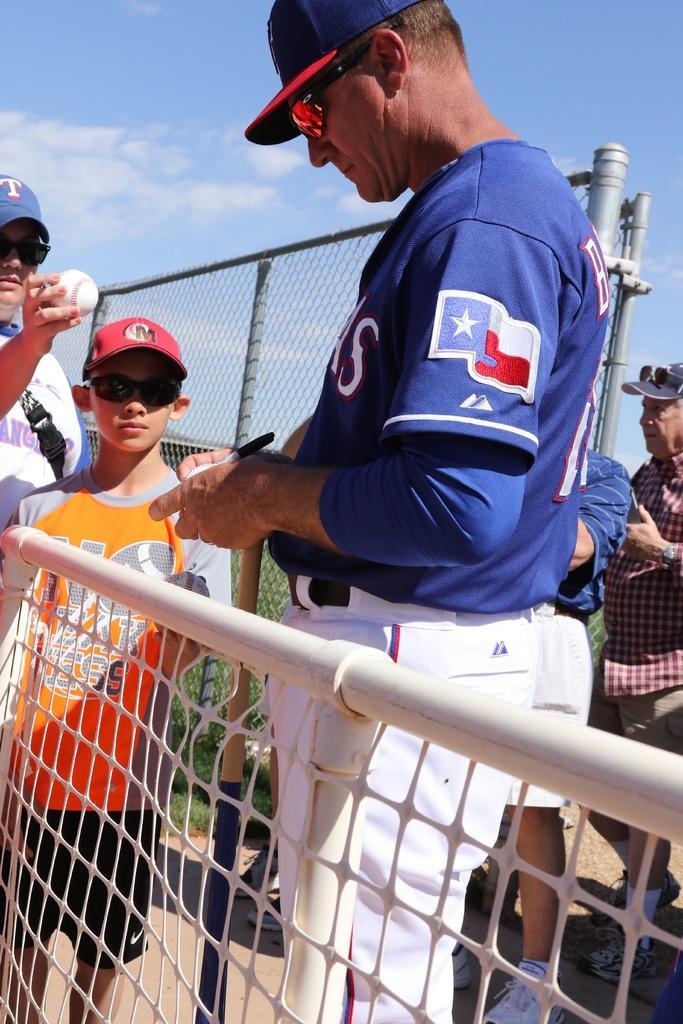Can you describe this image briefly? In this picture we can see people holding balls and wearing caps. They are standing between an iron gate and a fence. Here the sky is blue. 